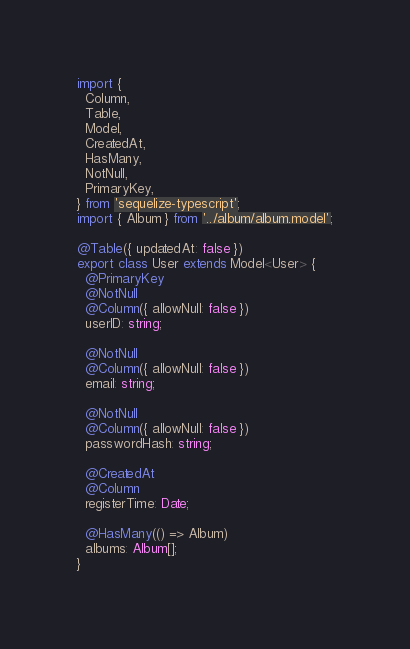<code> <loc_0><loc_0><loc_500><loc_500><_TypeScript_>import {
  Column,
  Table,
  Model,
  CreatedAt,
  HasMany,
  NotNull,
  PrimaryKey,
} from 'sequelize-typescript';
import { Album } from '../album/album.model';

@Table({ updatedAt: false })
export class User extends Model<User> {
  @PrimaryKey
  @NotNull
  @Column({ allowNull: false })
  userID: string;

  @NotNull
  @Column({ allowNull: false })
  email: string;

  @NotNull
  @Column({ allowNull: false })
  passwordHash: string;

  @CreatedAt
  @Column
  registerTime: Date;

  @HasMany(() => Album)
  albums: Album[];
}
</code> 